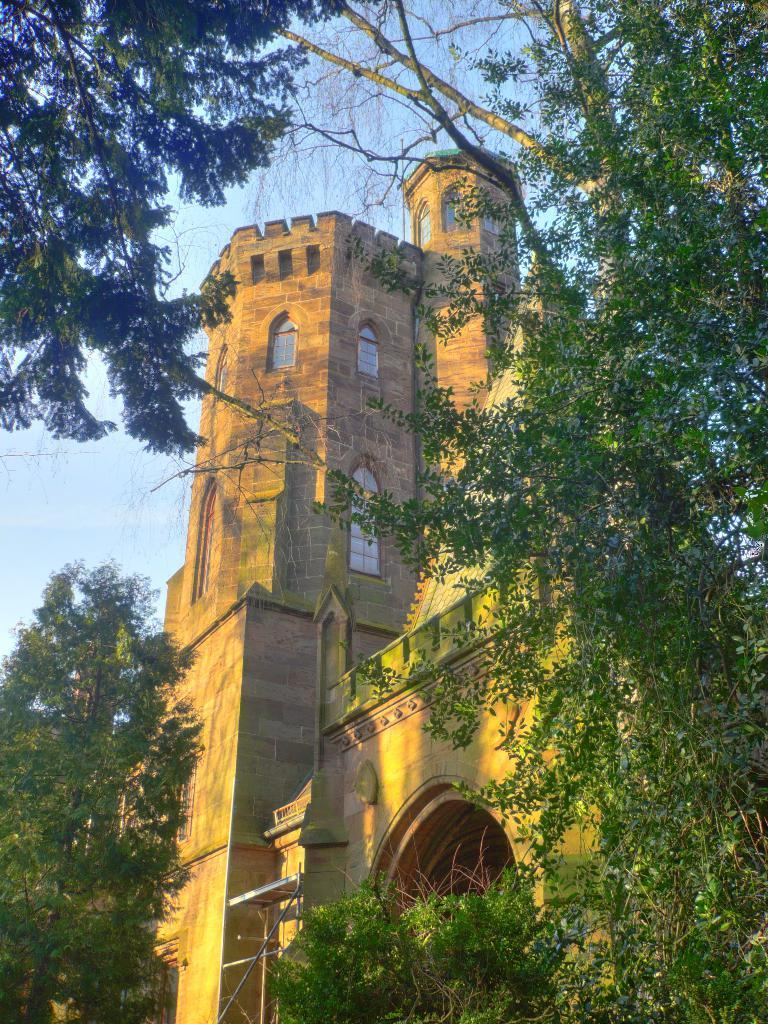What type of vegetation can be seen in the image? There are trees in the image. What type of structure is visible in the background of the image? There is a castle in the background of the image. What part of the natural environment is visible in the image? The sky is visible in the background of the image. What type of skirt is hanging on the tree in the image? There is no skirt present in the image; it features trees and a castle in the background. How quiet is the environment in the image? The image does not provide any information about the noise level or quietness of the environment. 